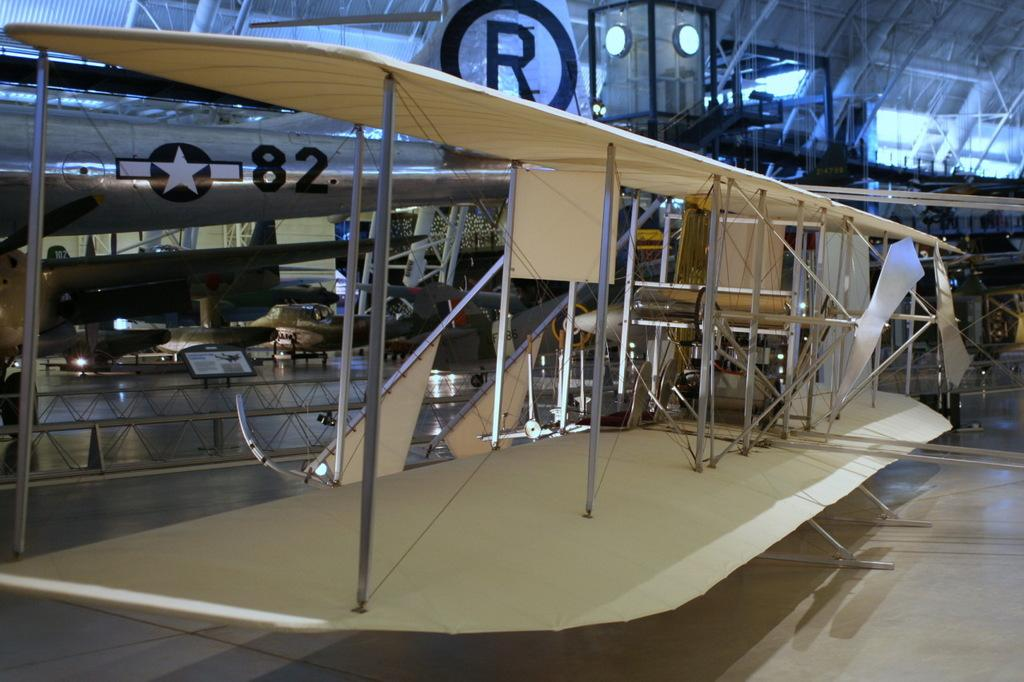What type of airplane is in the picture? There is a stearman, a type of airplane, in the picture. What else can be seen in the picture besides the stearman? There are other things visible behind the stearman. Can you describe the board in the image? There is a board on a path in the image. What type of snow can be seen falling from the sky in the image? There is no snow visible in the image; it is an image of a stearman airplane with other elements in the background. 